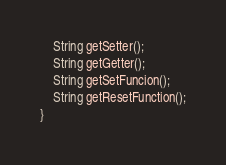Convert code to text. <code><loc_0><loc_0><loc_500><loc_500><_Java_>    String getSetter();
    String getGetter();
    String getSetFuncion();
    String getResetFunction();
}
</code> 